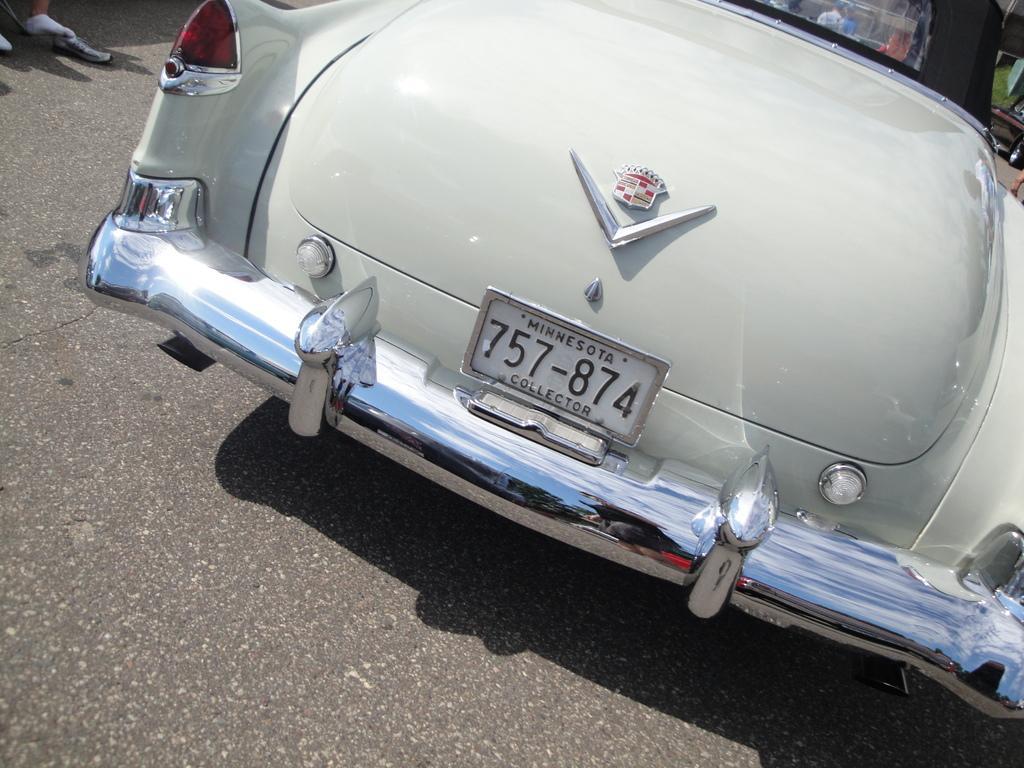Please provide a concise description of this image. In this picture I can see a vehicle on the road. 